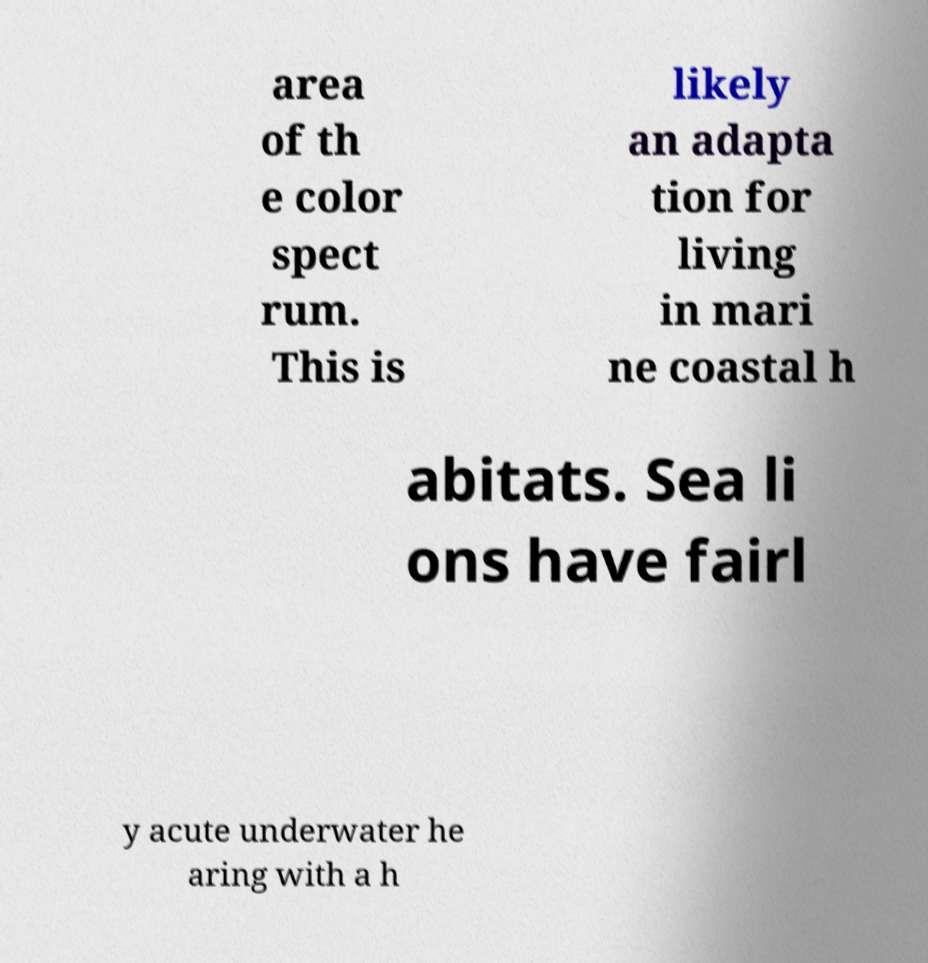For documentation purposes, I need the text within this image transcribed. Could you provide that? area of th e color spect rum. This is likely an adapta tion for living in mari ne coastal h abitats. Sea li ons have fairl y acute underwater he aring with a h 